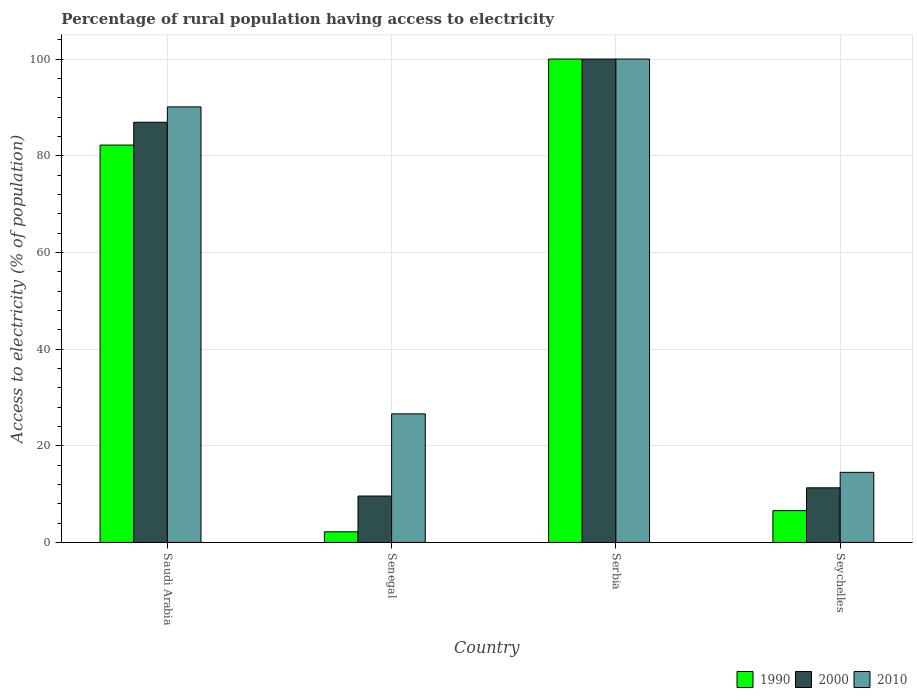How many groups of bars are there?
Give a very brief answer. 4. Are the number of bars on each tick of the X-axis equal?
Offer a terse response. Yes. How many bars are there on the 1st tick from the right?
Make the answer very short. 3. What is the label of the 2nd group of bars from the left?
Your response must be concise. Senegal. What is the percentage of rural population having access to electricity in 1990 in Senegal?
Offer a terse response. 2.2. In which country was the percentage of rural population having access to electricity in 2010 maximum?
Your answer should be very brief. Serbia. In which country was the percentage of rural population having access to electricity in 2010 minimum?
Your answer should be compact. Seychelles. What is the total percentage of rural population having access to electricity in 2000 in the graph?
Your response must be concise. 207.83. What is the difference between the percentage of rural population having access to electricity in 2000 in Senegal and that in Serbia?
Make the answer very short. -90.4. What is the difference between the percentage of rural population having access to electricity in 2010 in Serbia and the percentage of rural population having access to electricity in 1990 in Saudi Arabia?
Offer a very short reply. 17.8. What is the average percentage of rural population having access to electricity in 2010 per country?
Provide a short and direct response. 57.8. What is the difference between the percentage of rural population having access to electricity of/in 2000 and percentage of rural population having access to electricity of/in 2010 in Serbia?
Offer a very short reply. 0. What is the ratio of the percentage of rural population having access to electricity in 2010 in Saudi Arabia to that in Senegal?
Give a very brief answer. 3.39. Is the difference between the percentage of rural population having access to electricity in 2000 in Saudi Arabia and Seychelles greater than the difference between the percentage of rural population having access to electricity in 2010 in Saudi Arabia and Seychelles?
Your answer should be compact. Yes. What is the difference between the highest and the second highest percentage of rural population having access to electricity in 2010?
Your response must be concise. 63.5. What is the difference between the highest and the lowest percentage of rural population having access to electricity in 1990?
Offer a very short reply. 97.8. What does the 3rd bar from the left in Serbia represents?
Ensure brevity in your answer.  2010. Is it the case that in every country, the sum of the percentage of rural population having access to electricity in 2010 and percentage of rural population having access to electricity in 2000 is greater than the percentage of rural population having access to electricity in 1990?
Ensure brevity in your answer.  Yes. Are all the bars in the graph horizontal?
Provide a succinct answer. No. Are the values on the major ticks of Y-axis written in scientific E-notation?
Provide a succinct answer. No. Does the graph contain grids?
Your answer should be very brief. Yes. Where does the legend appear in the graph?
Keep it short and to the point. Bottom right. How many legend labels are there?
Provide a short and direct response. 3. What is the title of the graph?
Your answer should be compact. Percentage of rural population having access to electricity. Does "2013" appear as one of the legend labels in the graph?
Offer a very short reply. No. What is the label or title of the Y-axis?
Give a very brief answer. Access to electricity (% of population). What is the Access to electricity (% of population) in 1990 in Saudi Arabia?
Provide a succinct answer. 82.2. What is the Access to electricity (% of population) in 2000 in Saudi Arabia?
Keep it short and to the point. 86.93. What is the Access to electricity (% of population) of 2010 in Saudi Arabia?
Provide a short and direct response. 90.1. What is the Access to electricity (% of population) in 2000 in Senegal?
Your answer should be compact. 9.6. What is the Access to electricity (% of population) in 2010 in Senegal?
Provide a short and direct response. 26.6. What is the Access to electricity (% of population) of 2000 in Serbia?
Make the answer very short. 100. What is the Access to electricity (% of population) of 1990 in Seychelles?
Offer a terse response. 6.58. What is the Access to electricity (% of population) of 2000 in Seychelles?
Offer a terse response. 11.3. What is the Access to electricity (% of population) in 2010 in Seychelles?
Provide a succinct answer. 14.5. Across all countries, what is the minimum Access to electricity (% of population) of 2000?
Give a very brief answer. 9.6. Across all countries, what is the minimum Access to electricity (% of population) of 2010?
Your answer should be compact. 14.5. What is the total Access to electricity (% of population) in 1990 in the graph?
Your response must be concise. 190.98. What is the total Access to electricity (% of population) of 2000 in the graph?
Keep it short and to the point. 207.83. What is the total Access to electricity (% of population) in 2010 in the graph?
Your answer should be very brief. 231.2. What is the difference between the Access to electricity (% of population) of 1990 in Saudi Arabia and that in Senegal?
Give a very brief answer. 80. What is the difference between the Access to electricity (% of population) of 2000 in Saudi Arabia and that in Senegal?
Ensure brevity in your answer.  77.33. What is the difference between the Access to electricity (% of population) in 2010 in Saudi Arabia and that in Senegal?
Offer a very short reply. 63.5. What is the difference between the Access to electricity (% of population) in 1990 in Saudi Arabia and that in Serbia?
Your answer should be compact. -17.8. What is the difference between the Access to electricity (% of population) of 2000 in Saudi Arabia and that in Serbia?
Keep it short and to the point. -13.07. What is the difference between the Access to electricity (% of population) of 2010 in Saudi Arabia and that in Serbia?
Provide a short and direct response. -9.9. What is the difference between the Access to electricity (% of population) of 1990 in Saudi Arabia and that in Seychelles?
Your answer should be very brief. 75.62. What is the difference between the Access to electricity (% of population) of 2000 in Saudi Arabia and that in Seychelles?
Offer a very short reply. 75.62. What is the difference between the Access to electricity (% of population) of 2010 in Saudi Arabia and that in Seychelles?
Offer a very short reply. 75.6. What is the difference between the Access to electricity (% of population) of 1990 in Senegal and that in Serbia?
Provide a short and direct response. -97.8. What is the difference between the Access to electricity (% of population) of 2000 in Senegal and that in Serbia?
Offer a terse response. -90.4. What is the difference between the Access to electricity (% of population) of 2010 in Senegal and that in Serbia?
Provide a short and direct response. -73.4. What is the difference between the Access to electricity (% of population) of 1990 in Senegal and that in Seychelles?
Keep it short and to the point. -4.38. What is the difference between the Access to electricity (% of population) in 2000 in Senegal and that in Seychelles?
Your answer should be very brief. -1.7. What is the difference between the Access to electricity (% of population) of 1990 in Serbia and that in Seychelles?
Provide a succinct answer. 93.42. What is the difference between the Access to electricity (% of population) in 2000 in Serbia and that in Seychelles?
Your response must be concise. 88.7. What is the difference between the Access to electricity (% of population) in 2010 in Serbia and that in Seychelles?
Your answer should be compact. 85.5. What is the difference between the Access to electricity (% of population) of 1990 in Saudi Arabia and the Access to electricity (% of population) of 2000 in Senegal?
Provide a succinct answer. 72.6. What is the difference between the Access to electricity (% of population) of 1990 in Saudi Arabia and the Access to electricity (% of population) of 2010 in Senegal?
Give a very brief answer. 55.6. What is the difference between the Access to electricity (% of population) of 2000 in Saudi Arabia and the Access to electricity (% of population) of 2010 in Senegal?
Ensure brevity in your answer.  60.33. What is the difference between the Access to electricity (% of population) in 1990 in Saudi Arabia and the Access to electricity (% of population) in 2000 in Serbia?
Ensure brevity in your answer.  -17.8. What is the difference between the Access to electricity (% of population) in 1990 in Saudi Arabia and the Access to electricity (% of population) in 2010 in Serbia?
Keep it short and to the point. -17.8. What is the difference between the Access to electricity (% of population) in 2000 in Saudi Arabia and the Access to electricity (% of population) in 2010 in Serbia?
Make the answer very short. -13.07. What is the difference between the Access to electricity (% of population) in 1990 in Saudi Arabia and the Access to electricity (% of population) in 2000 in Seychelles?
Your response must be concise. 70.9. What is the difference between the Access to electricity (% of population) of 1990 in Saudi Arabia and the Access to electricity (% of population) of 2010 in Seychelles?
Ensure brevity in your answer.  67.7. What is the difference between the Access to electricity (% of population) of 2000 in Saudi Arabia and the Access to electricity (% of population) of 2010 in Seychelles?
Ensure brevity in your answer.  72.43. What is the difference between the Access to electricity (% of population) in 1990 in Senegal and the Access to electricity (% of population) in 2000 in Serbia?
Provide a short and direct response. -97.8. What is the difference between the Access to electricity (% of population) of 1990 in Senegal and the Access to electricity (% of population) of 2010 in Serbia?
Make the answer very short. -97.8. What is the difference between the Access to electricity (% of population) in 2000 in Senegal and the Access to electricity (% of population) in 2010 in Serbia?
Make the answer very short. -90.4. What is the difference between the Access to electricity (% of population) in 1990 in Senegal and the Access to electricity (% of population) in 2000 in Seychelles?
Ensure brevity in your answer.  -9.1. What is the difference between the Access to electricity (% of population) of 1990 in Serbia and the Access to electricity (% of population) of 2000 in Seychelles?
Give a very brief answer. 88.7. What is the difference between the Access to electricity (% of population) of 1990 in Serbia and the Access to electricity (% of population) of 2010 in Seychelles?
Give a very brief answer. 85.5. What is the difference between the Access to electricity (% of population) of 2000 in Serbia and the Access to electricity (% of population) of 2010 in Seychelles?
Make the answer very short. 85.5. What is the average Access to electricity (% of population) of 1990 per country?
Ensure brevity in your answer.  47.75. What is the average Access to electricity (% of population) of 2000 per country?
Provide a succinct answer. 51.96. What is the average Access to electricity (% of population) of 2010 per country?
Give a very brief answer. 57.8. What is the difference between the Access to electricity (% of population) in 1990 and Access to electricity (% of population) in 2000 in Saudi Arabia?
Offer a terse response. -4.72. What is the difference between the Access to electricity (% of population) in 1990 and Access to electricity (% of population) in 2010 in Saudi Arabia?
Give a very brief answer. -7.9. What is the difference between the Access to electricity (% of population) in 2000 and Access to electricity (% of population) in 2010 in Saudi Arabia?
Provide a succinct answer. -3.17. What is the difference between the Access to electricity (% of population) of 1990 and Access to electricity (% of population) of 2000 in Senegal?
Provide a succinct answer. -7.4. What is the difference between the Access to electricity (% of population) of 1990 and Access to electricity (% of population) of 2010 in Senegal?
Make the answer very short. -24.4. What is the difference between the Access to electricity (% of population) of 2000 and Access to electricity (% of population) of 2010 in Senegal?
Your answer should be compact. -17. What is the difference between the Access to electricity (% of population) of 1990 and Access to electricity (% of population) of 2000 in Seychelles?
Keep it short and to the point. -4.72. What is the difference between the Access to electricity (% of population) in 1990 and Access to electricity (% of population) in 2010 in Seychelles?
Ensure brevity in your answer.  -7.92. What is the difference between the Access to electricity (% of population) in 2000 and Access to electricity (% of population) in 2010 in Seychelles?
Keep it short and to the point. -3.2. What is the ratio of the Access to electricity (% of population) of 1990 in Saudi Arabia to that in Senegal?
Keep it short and to the point. 37.37. What is the ratio of the Access to electricity (% of population) in 2000 in Saudi Arabia to that in Senegal?
Your answer should be very brief. 9.05. What is the ratio of the Access to electricity (% of population) of 2010 in Saudi Arabia to that in Senegal?
Your response must be concise. 3.39. What is the ratio of the Access to electricity (% of population) of 1990 in Saudi Arabia to that in Serbia?
Offer a very short reply. 0.82. What is the ratio of the Access to electricity (% of population) in 2000 in Saudi Arabia to that in Serbia?
Your response must be concise. 0.87. What is the ratio of the Access to electricity (% of population) of 2010 in Saudi Arabia to that in Serbia?
Provide a succinct answer. 0.9. What is the ratio of the Access to electricity (% of population) in 1990 in Saudi Arabia to that in Seychelles?
Offer a terse response. 12.49. What is the ratio of the Access to electricity (% of population) of 2000 in Saudi Arabia to that in Seychelles?
Give a very brief answer. 7.69. What is the ratio of the Access to electricity (% of population) in 2010 in Saudi Arabia to that in Seychelles?
Provide a succinct answer. 6.21. What is the ratio of the Access to electricity (% of population) of 1990 in Senegal to that in Serbia?
Your answer should be very brief. 0.02. What is the ratio of the Access to electricity (% of population) of 2000 in Senegal to that in Serbia?
Offer a terse response. 0.1. What is the ratio of the Access to electricity (% of population) of 2010 in Senegal to that in Serbia?
Your answer should be very brief. 0.27. What is the ratio of the Access to electricity (% of population) of 1990 in Senegal to that in Seychelles?
Ensure brevity in your answer.  0.33. What is the ratio of the Access to electricity (% of population) of 2000 in Senegal to that in Seychelles?
Provide a short and direct response. 0.85. What is the ratio of the Access to electricity (% of population) in 2010 in Senegal to that in Seychelles?
Offer a terse response. 1.83. What is the ratio of the Access to electricity (% of population) in 1990 in Serbia to that in Seychelles?
Your answer should be compact. 15.2. What is the ratio of the Access to electricity (% of population) of 2000 in Serbia to that in Seychelles?
Provide a succinct answer. 8.85. What is the ratio of the Access to electricity (% of population) in 2010 in Serbia to that in Seychelles?
Keep it short and to the point. 6.9. What is the difference between the highest and the second highest Access to electricity (% of population) in 1990?
Keep it short and to the point. 17.8. What is the difference between the highest and the second highest Access to electricity (% of population) of 2000?
Your answer should be very brief. 13.07. What is the difference between the highest and the second highest Access to electricity (% of population) of 2010?
Offer a very short reply. 9.9. What is the difference between the highest and the lowest Access to electricity (% of population) of 1990?
Ensure brevity in your answer.  97.8. What is the difference between the highest and the lowest Access to electricity (% of population) of 2000?
Ensure brevity in your answer.  90.4. What is the difference between the highest and the lowest Access to electricity (% of population) in 2010?
Make the answer very short. 85.5. 